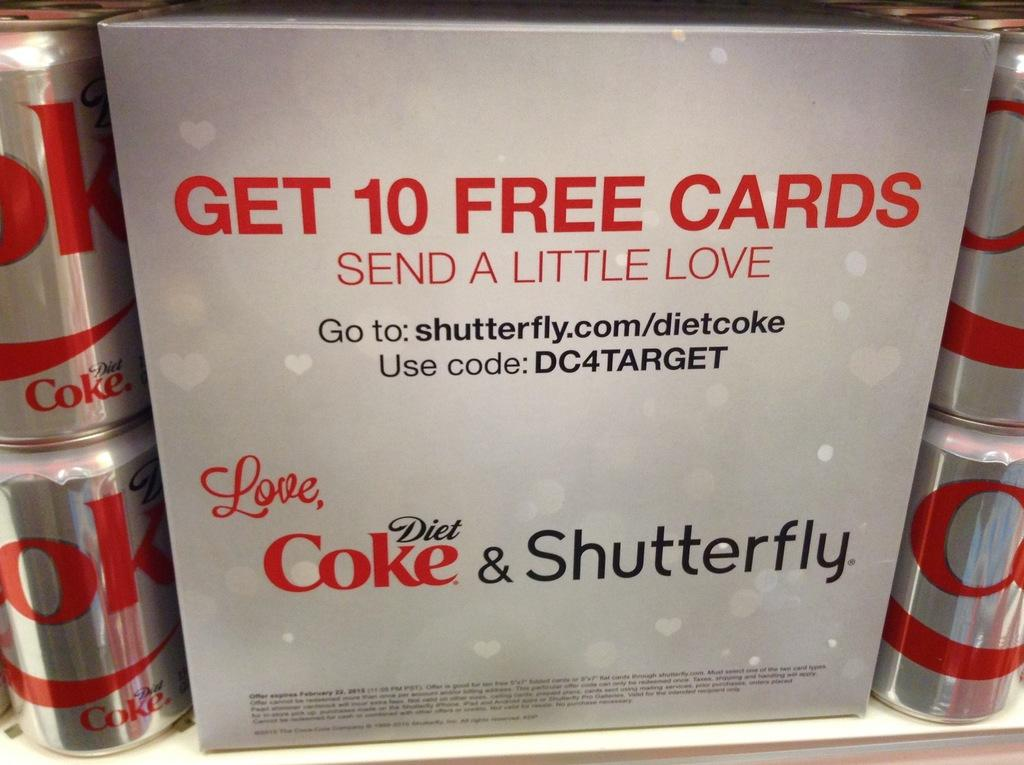<image>
Share a concise interpretation of the image provided. Diet Coke and Shutterfly are giving away cards. 